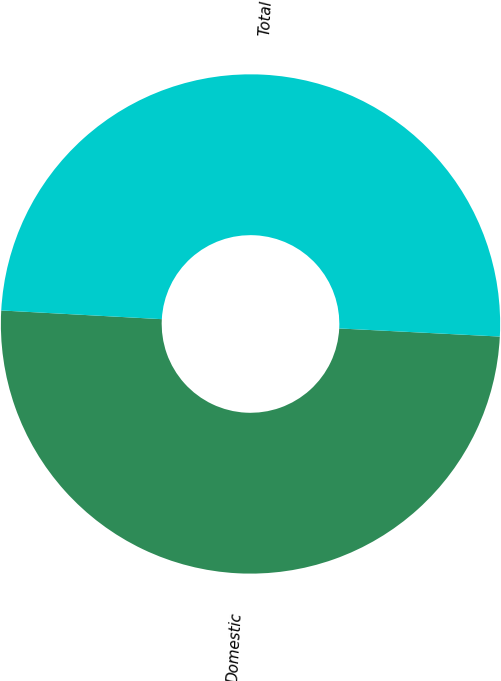Convert chart to OTSL. <chart><loc_0><loc_0><loc_500><loc_500><pie_chart><fcel>Domestic<fcel>Total<nl><fcel>50.06%<fcel>49.94%<nl></chart> 